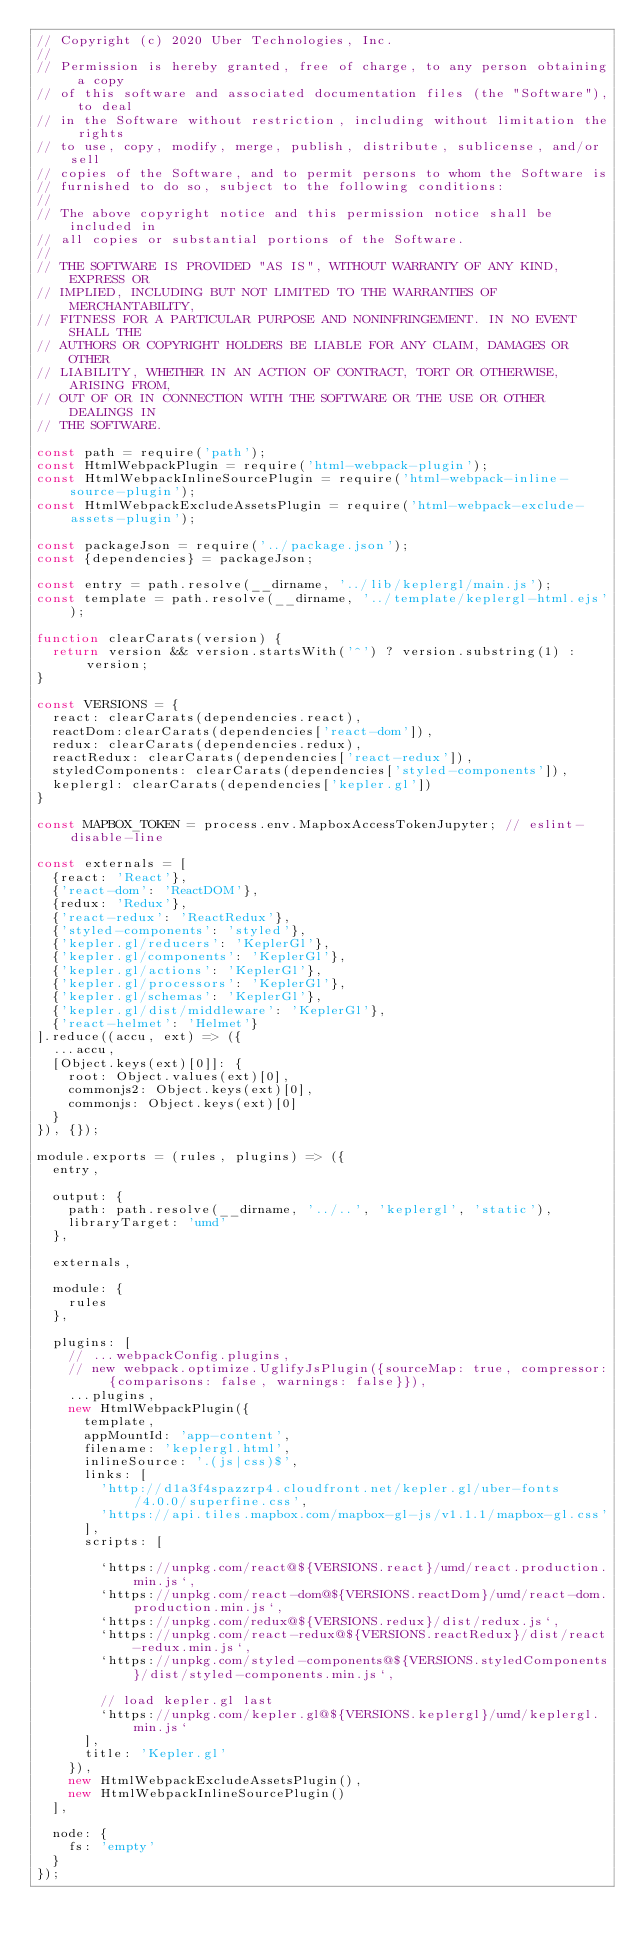<code> <loc_0><loc_0><loc_500><loc_500><_JavaScript_>// Copyright (c) 2020 Uber Technologies, Inc.
//
// Permission is hereby granted, free of charge, to any person obtaining a copy
// of this software and associated documentation files (the "Software"), to deal
// in the Software without restriction, including without limitation the rights
// to use, copy, modify, merge, publish, distribute, sublicense, and/or sell
// copies of the Software, and to permit persons to whom the Software is
// furnished to do so, subject to the following conditions:
//
// The above copyright notice and this permission notice shall be included in
// all copies or substantial portions of the Software.
//
// THE SOFTWARE IS PROVIDED "AS IS", WITHOUT WARRANTY OF ANY KIND, EXPRESS OR
// IMPLIED, INCLUDING BUT NOT LIMITED TO THE WARRANTIES OF MERCHANTABILITY,
// FITNESS FOR A PARTICULAR PURPOSE AND NONINFRINGEMENT. IN NO EVENT SHALL THE
// AUTHORS OR COPYRIGHT HOLDERS BE LIABLE FOR ANY CLAIM, DAMAGES OR OTHER
// LIABILITY, WHETHER IN AN ACTION OF CONTRACT, TORT OR OTHERWISE, ARISING FROM,
// OUT OF OR IN CONNECTION WITH THE SOFTWARE OR THE USE OR OTHER DEALINGS IN
// THE SOFTWARE.

const path = require('path');
const HtmlWebpackPlugin = require('html-webpack-plugin');
const HtmlWebpackInlineSourcePlugin = require('html-webpack-inline-source-plugin');
const HtmlWebpackExcludeAssetsPlugin = require('html-webpack-exclude-assets-plugin');

const packageJson = require('../package.json');
const {dependencies} = packageJson;

const entry = path.resolve(__dirname, '../lib/keplergl/main.js');
const template = path.resolve(__dirname, '../template/keplergl-html.ejs');

function clearCarats(version) {
  return version && version.startsWith('^') ? version.substring(1) : version;
}

const VERSIONS = {
  react: clearCarats(dependencies.react),
  reactDom:clearCarats(dependencies['react-dom']),
  redux: clearCarats(dependencies.redux),
  reactRedux: clearCarats(dependencies['react-redux']),
  styledComponents: clearCarats(dependencies['styled-components']),
  keplergl: clearCarats(dependencies['kepler.gl'])
}

const MAPBOX_TOKEN = process.env.MapboxAccessTokenJupyter; // eslint-disable-line

const externals = [
  {react: 'React'},
  {'react-dom': 'ReactDOM'},
  {redux: 'Redux'},
  {'react-redux': 'ReactRedux'},
  {'styled-components': 'styled'},
  {'kepler.gl/reducers': 'KeplerGl'},
  {'kepler.gl/components': 'KeplerGl'},
  {'kepler.gl/actions': 'KeplerGl'},
  {'kepler.gl/processors': 'KeplerGl'},
  {'kepler.gl/schemas': 'KeplerGl'},
  {'kepler.gl/dist/middleware': 'KeplerGl'},
  {'react-helmet': 'Helmet'}
].reduce((accu, ext) => ({
  ...accu,
  [Object.keys(ext)[0]]: {
    root: Object.values(ext)[0],
    commonjs2: Object.keys(ext)[0],
    commonjs: Object.keys(ext)[0]
  }
}), {});

module.exports = (rules, plugins) => ({
  entry,

  output: {
    path: path.resolve(__dirname, '../..', 'keplergl', 'static'),
    libraryTarget: 'umd'
  },

  externals,

  module: {
    rules
  },

  plugins: [
    // ...webpackConfig.plugins,
    // new webpack.optimize.UglifyJsPlugin({sourceMap: true, compressor: {comparisons: false, warnings: false}}),
    ...plugins,
    new HtmlWebpackPlugin({
      template,
      appMountId: 'app-content',
      filename: 'keplergl.html',
      inlineSource: '.(js|css)$',
      links: [
        'http://d1a3f4spazzrp4.cloudfront.net/kepler.gl/uber-fonts/4.0.0/superfine.css',
        'https://api.tiles.mapbox.com/mapbox-gl-js/v1.1.1/mapbox-gl.css'
      ],
      scripts: [

        `https://unpkg.com/react@${VERSIONS.react}/umd/react.production.min.js`,
        `https://unpkg.com/react-dom@${VERSIONS.reactDom}/umd/react-dom.production.min.js`,
        `https://unpkg.com/redux@${VERSIONS.redux}/dist/redux.js`,
        `https://unpkg.com/react-redux@${VERSIONS.reactRedux}/dist/react-redux.min.js`,
        `https://unpkg.com/styled-components@${VERSIONS.styledComponents}/dist/styled-components.min.js`,

        // load kepler.gl last
        `https://unpkg.com/kepler.gl@${VERSIONS.keplergl}/umd/keplergl.min.js`
      ],
      title: 'Kepler.gl'
    }),
    new HtmlWebpackExcludeAssetsPlugin(),
    new HtmlWebpackInlineSourcePlugin()
  ],

  node: {
    fs: 'empty'
  }
});
</code> 